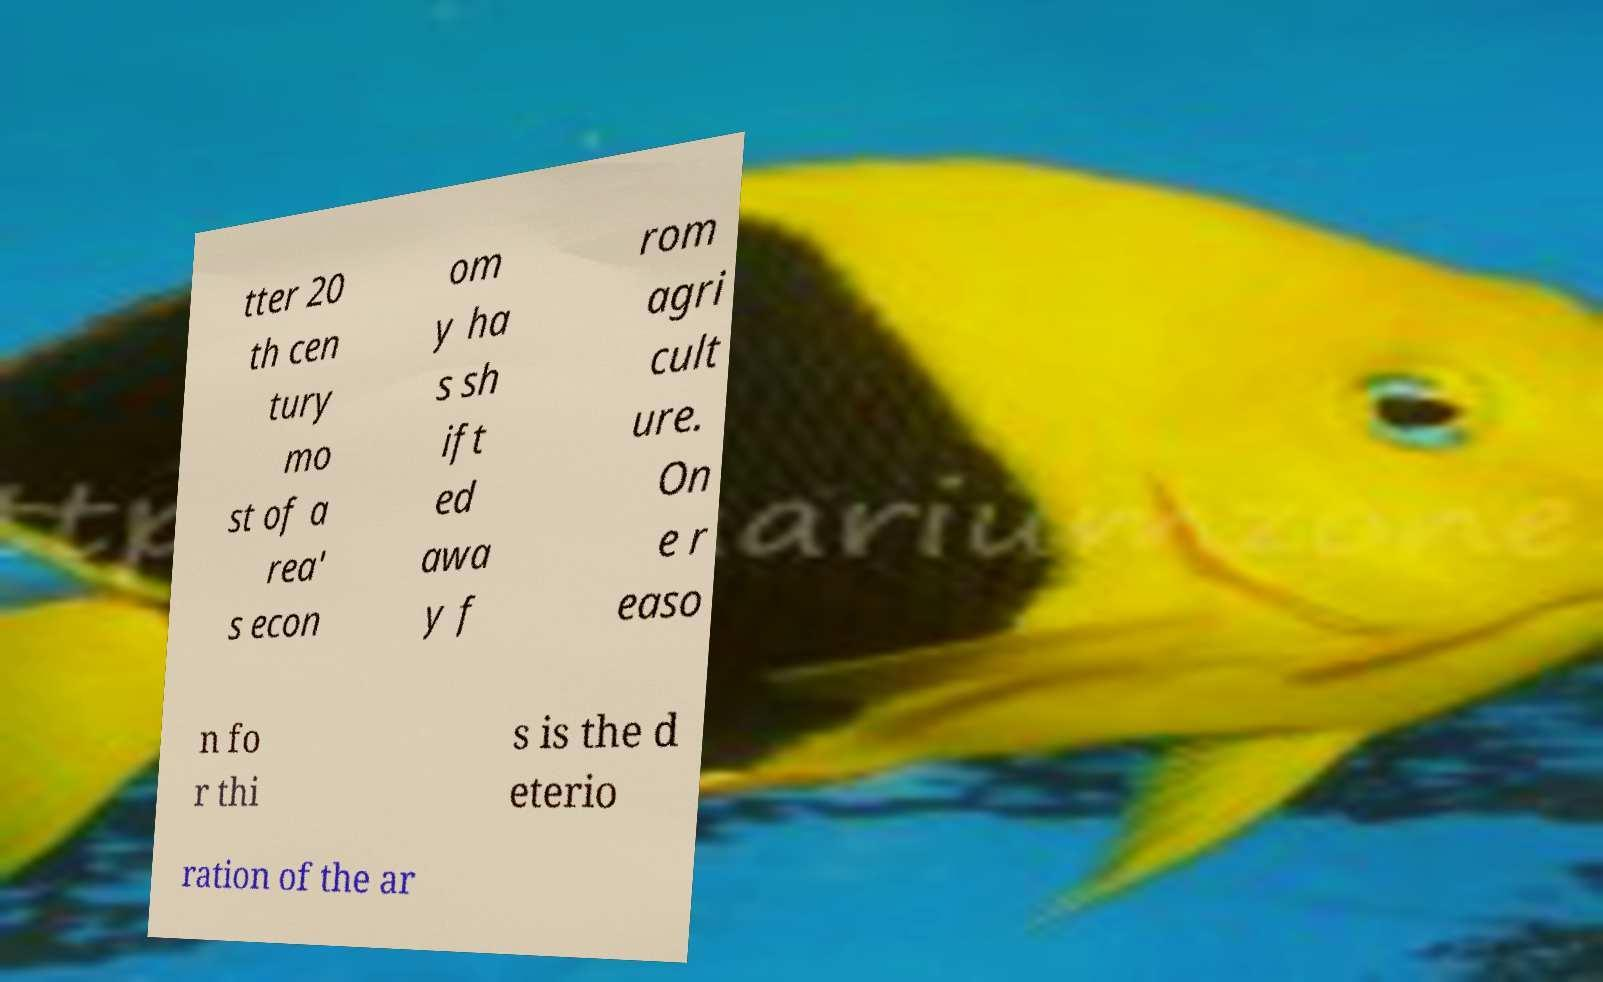There's text embedded in this image that I need extracted. Can you transcribe it verbatim? tter 20 th cen tury mo st of a rea' s econ om y ha s sh ift ed awa y f rom agri cult ure. On e r easo n fo r thi s is the d eterio ration of the ar 